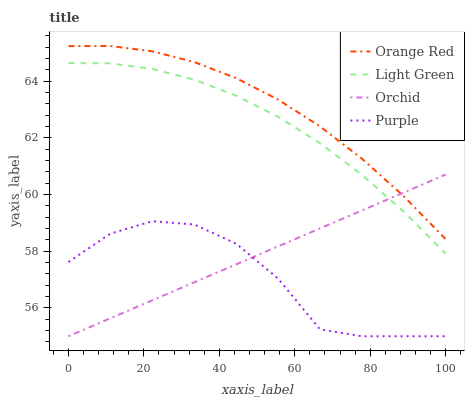Does Purple have the minimum area under the curve?
Answer yes or no. Yes. Does Orange Red have the maximum area under the curve?
Answer yes or no. Yes. Does Light Green have the minimum area under the curve?
Answer yes or no. No. Does Light Green have the maximum area under the curve?
Answer yes or no. No. Is Orchid the smoothest?
Answer yes or no. Yes. Is Purple the roughest?
Answer yes or no. Yes. Is Orange Red the smoothest?
Answer yes or no. No. Is Orange Red the roughest?
Answer yes or no. No. Does Purple have the lowest value?
Answer yes or no. Yes. Does Light Green have the lowest value?
Answer yes or no. No. Does Orange Red have the highest value?
Answer yes or no. Yes. Does Light Green have the highest value?
Answer yes or no. No. Is Purple less than Orange Red?
Answer yes or no. Yes. Is Orange Red greater than Purple?
Answer yes or no. Yes. Does Light Green intersect Orchid?
Answer yes or no. Yes. Is Light Green less than Orchid?
Answer yes or no. No. Is Light Green greater than Orchid?
Answer yes or no. No. Does Purple intersect Orange Red?
Answer yes or no. No. 